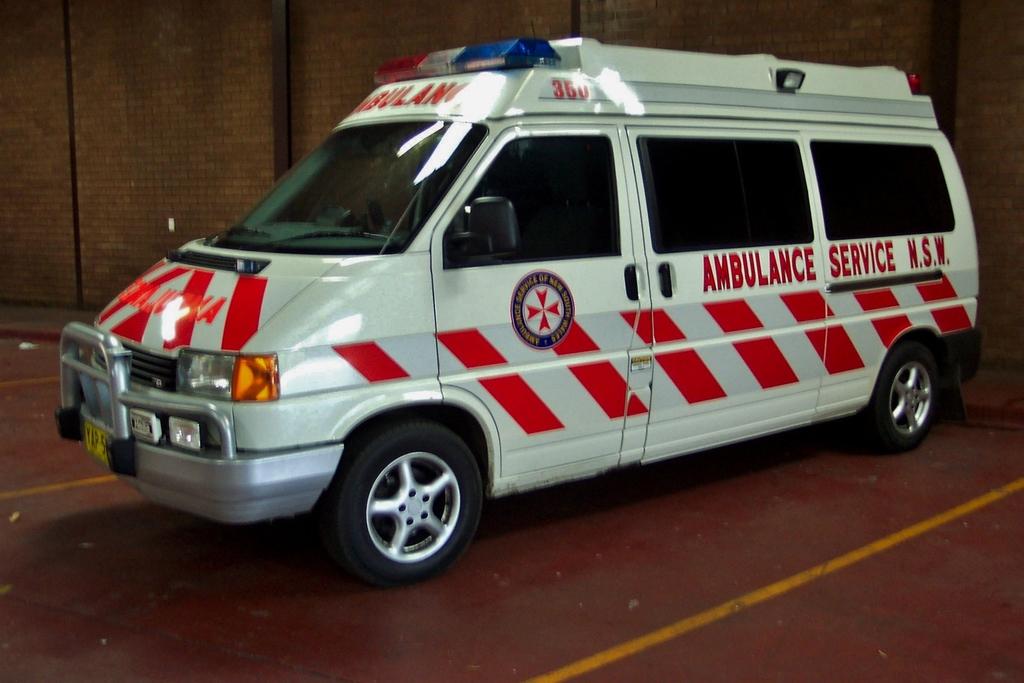What type of service?
Your answer should be compact. Ambulance. 